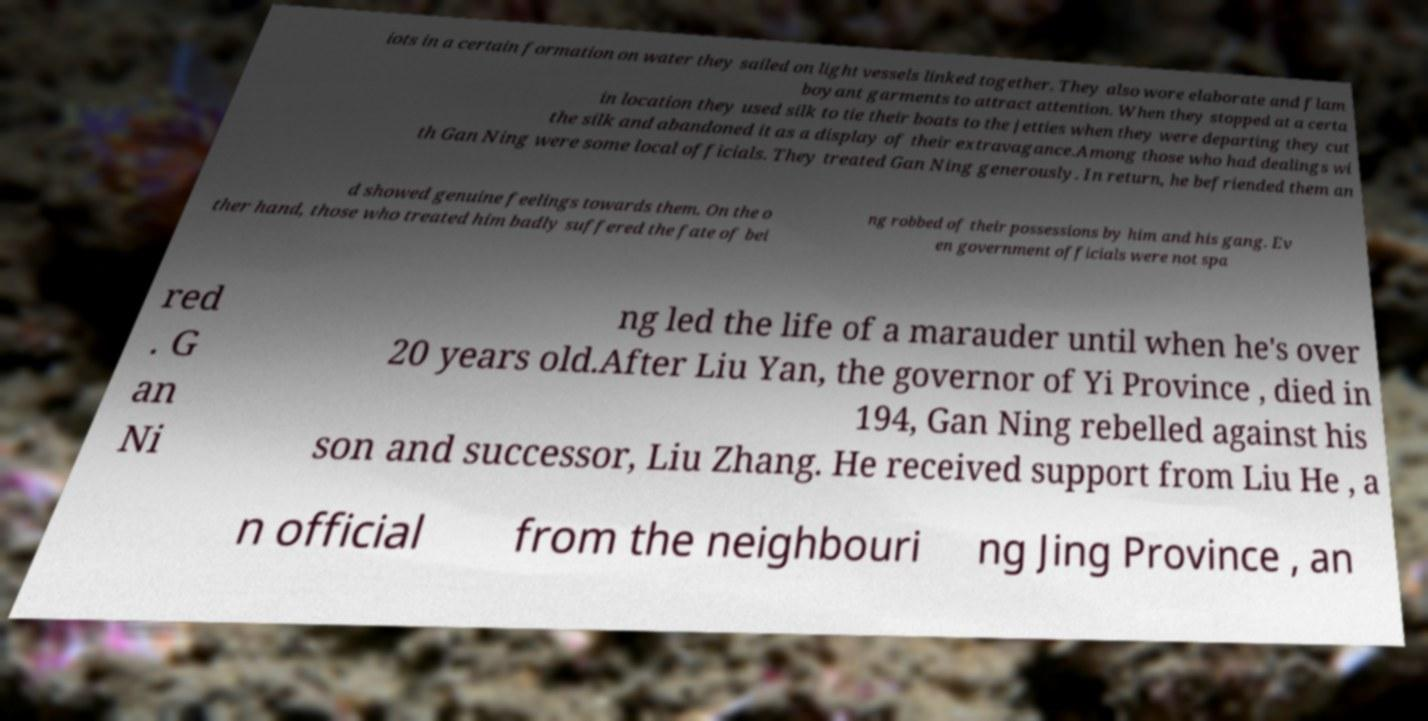Could you extract and type out the text from this image? iots in a certain formation on water they sailed on light vessels linked together. They also wore elaborate and flam boyant garments to attract attention. When they stopped at a certa in location they used silk to tie their boats to the jetties when they were departing they cut the silk and abandoned it as a display of their extravagance.Among those who had dealings wi th Gan Ning were some local officials. They treated Gan Ning generously. In return, he befriended them an d showed genuine feelings towards them. On the o ther hand, those who treated him badly suffered the fate of bei ng robbed of their possessions by him and his gang. Ev en government officials were not spa red . G an Ni ng led the life of a marauder until when he's over 20 years old.After Liu Yan, the governor of Yi Province , died in 194, Gan Ning rebelled against his son and successor, Liu Zhang. He received support from Liu He , a n official from the neighbouri ng Jing Province , an 